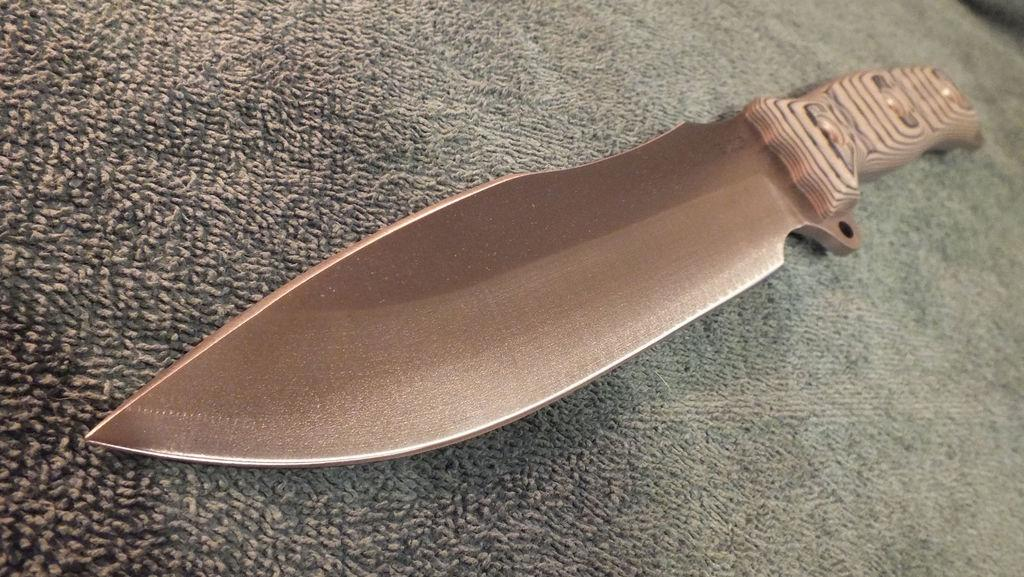What object is present in the image that can be used for cutting? There is a knife in the image. Where is the knife located in the image? The knife is on a surface. What type of quill is being used to write the title in the image? There is no quill or title present in the image; it only features a knife on a surface. 